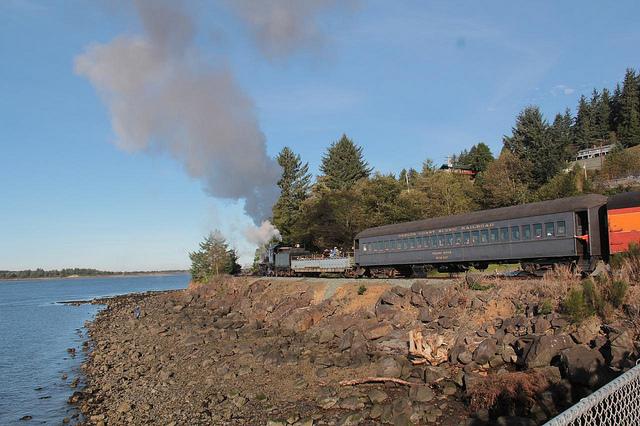Is the trees on fire?
Answer briefly. No. Is this a newer train?
Write a very short answer. No. Is this a steam engine?
Answer briefly. Yes. Is there any water showing?
Concise answer only. Yes. 